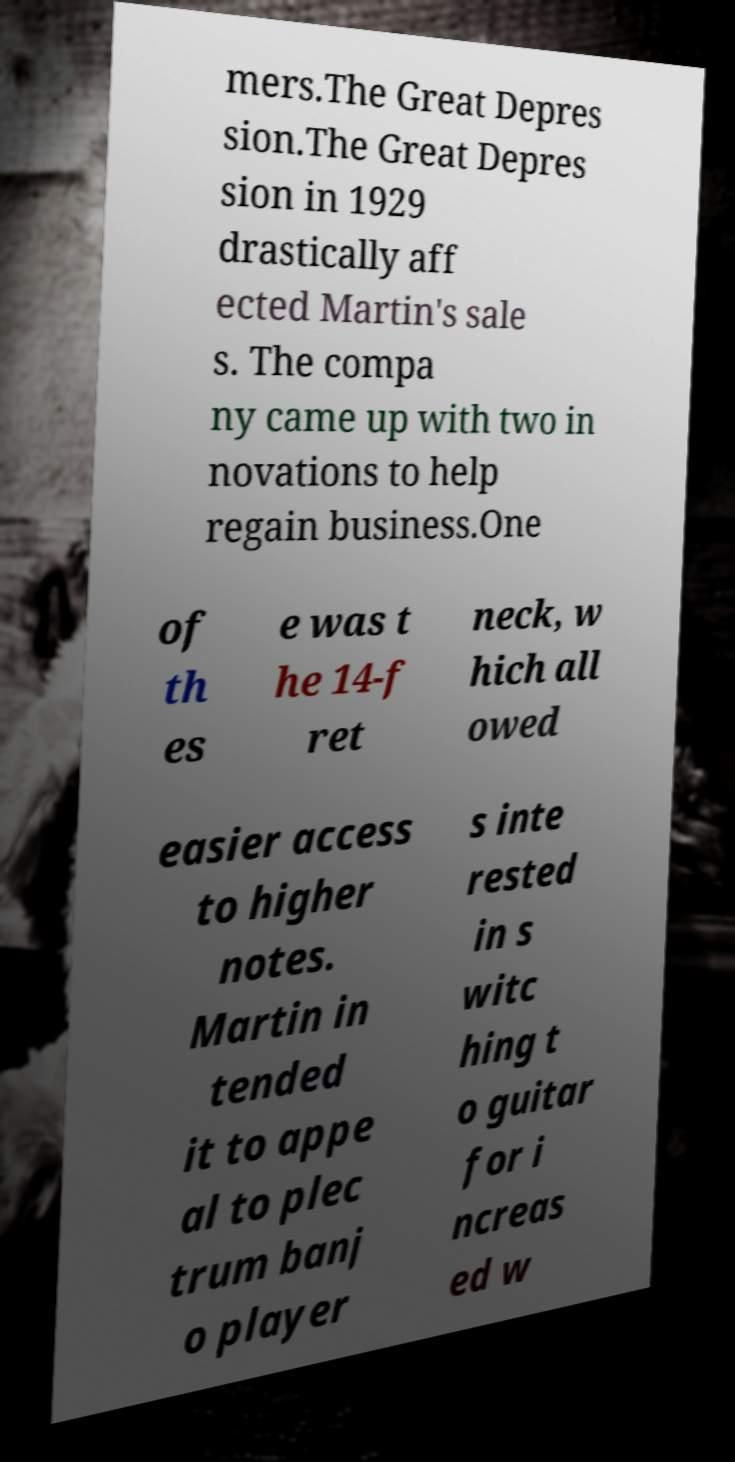Please identify and transcribe the text found in this image. mers.The Great Depres sion.The Great Depres sion in 1929 drastically aff ected Martin's sale s. The compa ny came up with two in novations to help regain business.One of th es e was t he 14-f ret neck, w hich all owed easier access to higher notes. Martin in tended it to appe al to plec trum banj o player s inte rested in s witc hing t o guitar for i ncreas ed w 